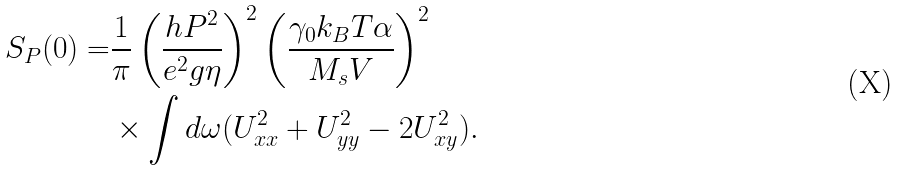<formula> <loc_0><loc_0><loc_500><loc_500>S _ { P } ( 0 ) = & \frac { 1 } { \pi } \left ( \frac { h P ^ { 2 } } { e ^ { 2 } g \eta } \right ) ^ { 2 } \left ( \frac { \gamma _ { 0 } k _ { B } T \alpha } { M _ { s } V } \right ) ^ { 2 } \\ & \times \int d \omega ( U _ { x x } ^ { 2 } + U _ { y y } ^ { 2 } - 2 U _ { x y } ^ { 2 } ) .</formula> 